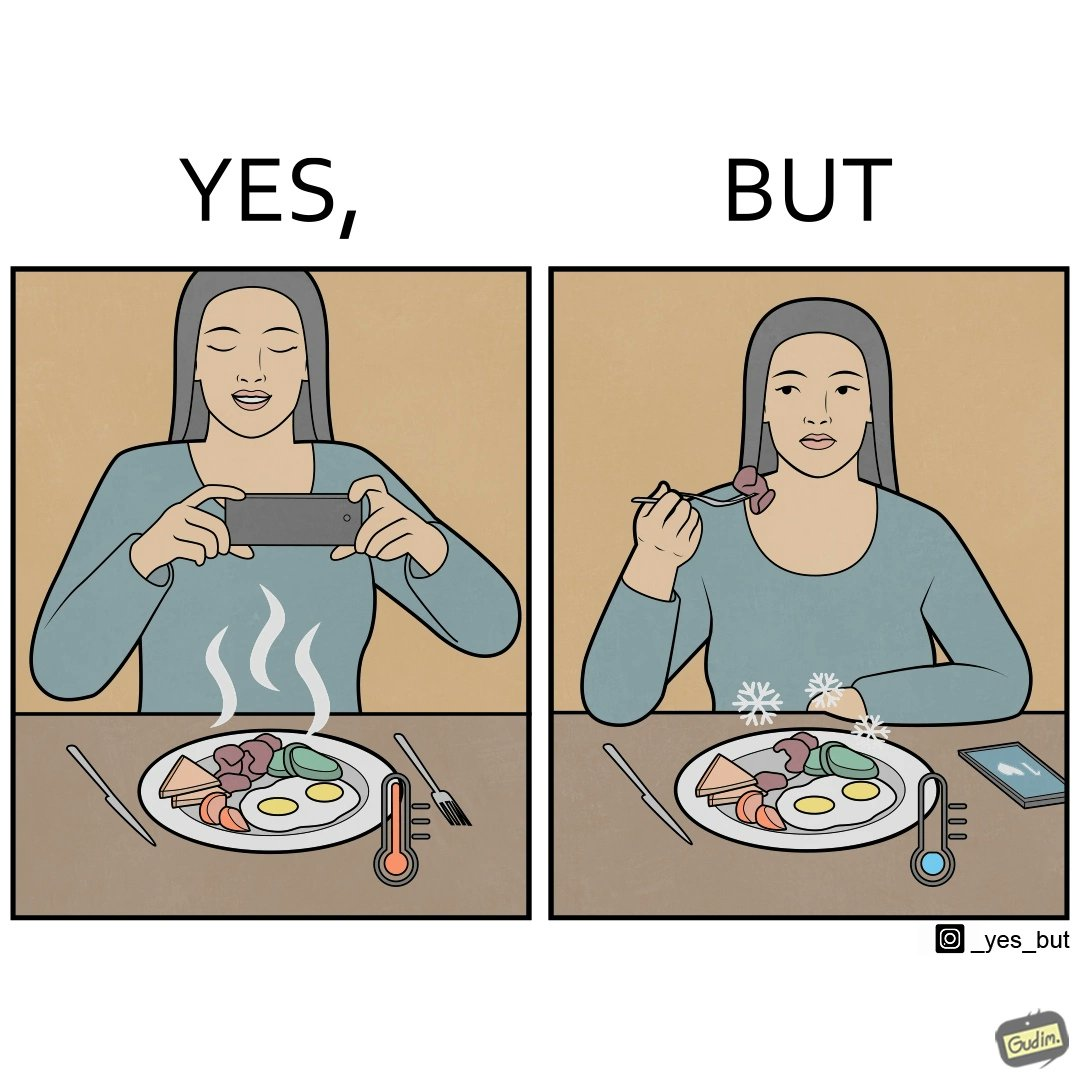Is there satirical content in this image? Yes, this image is satirical. 